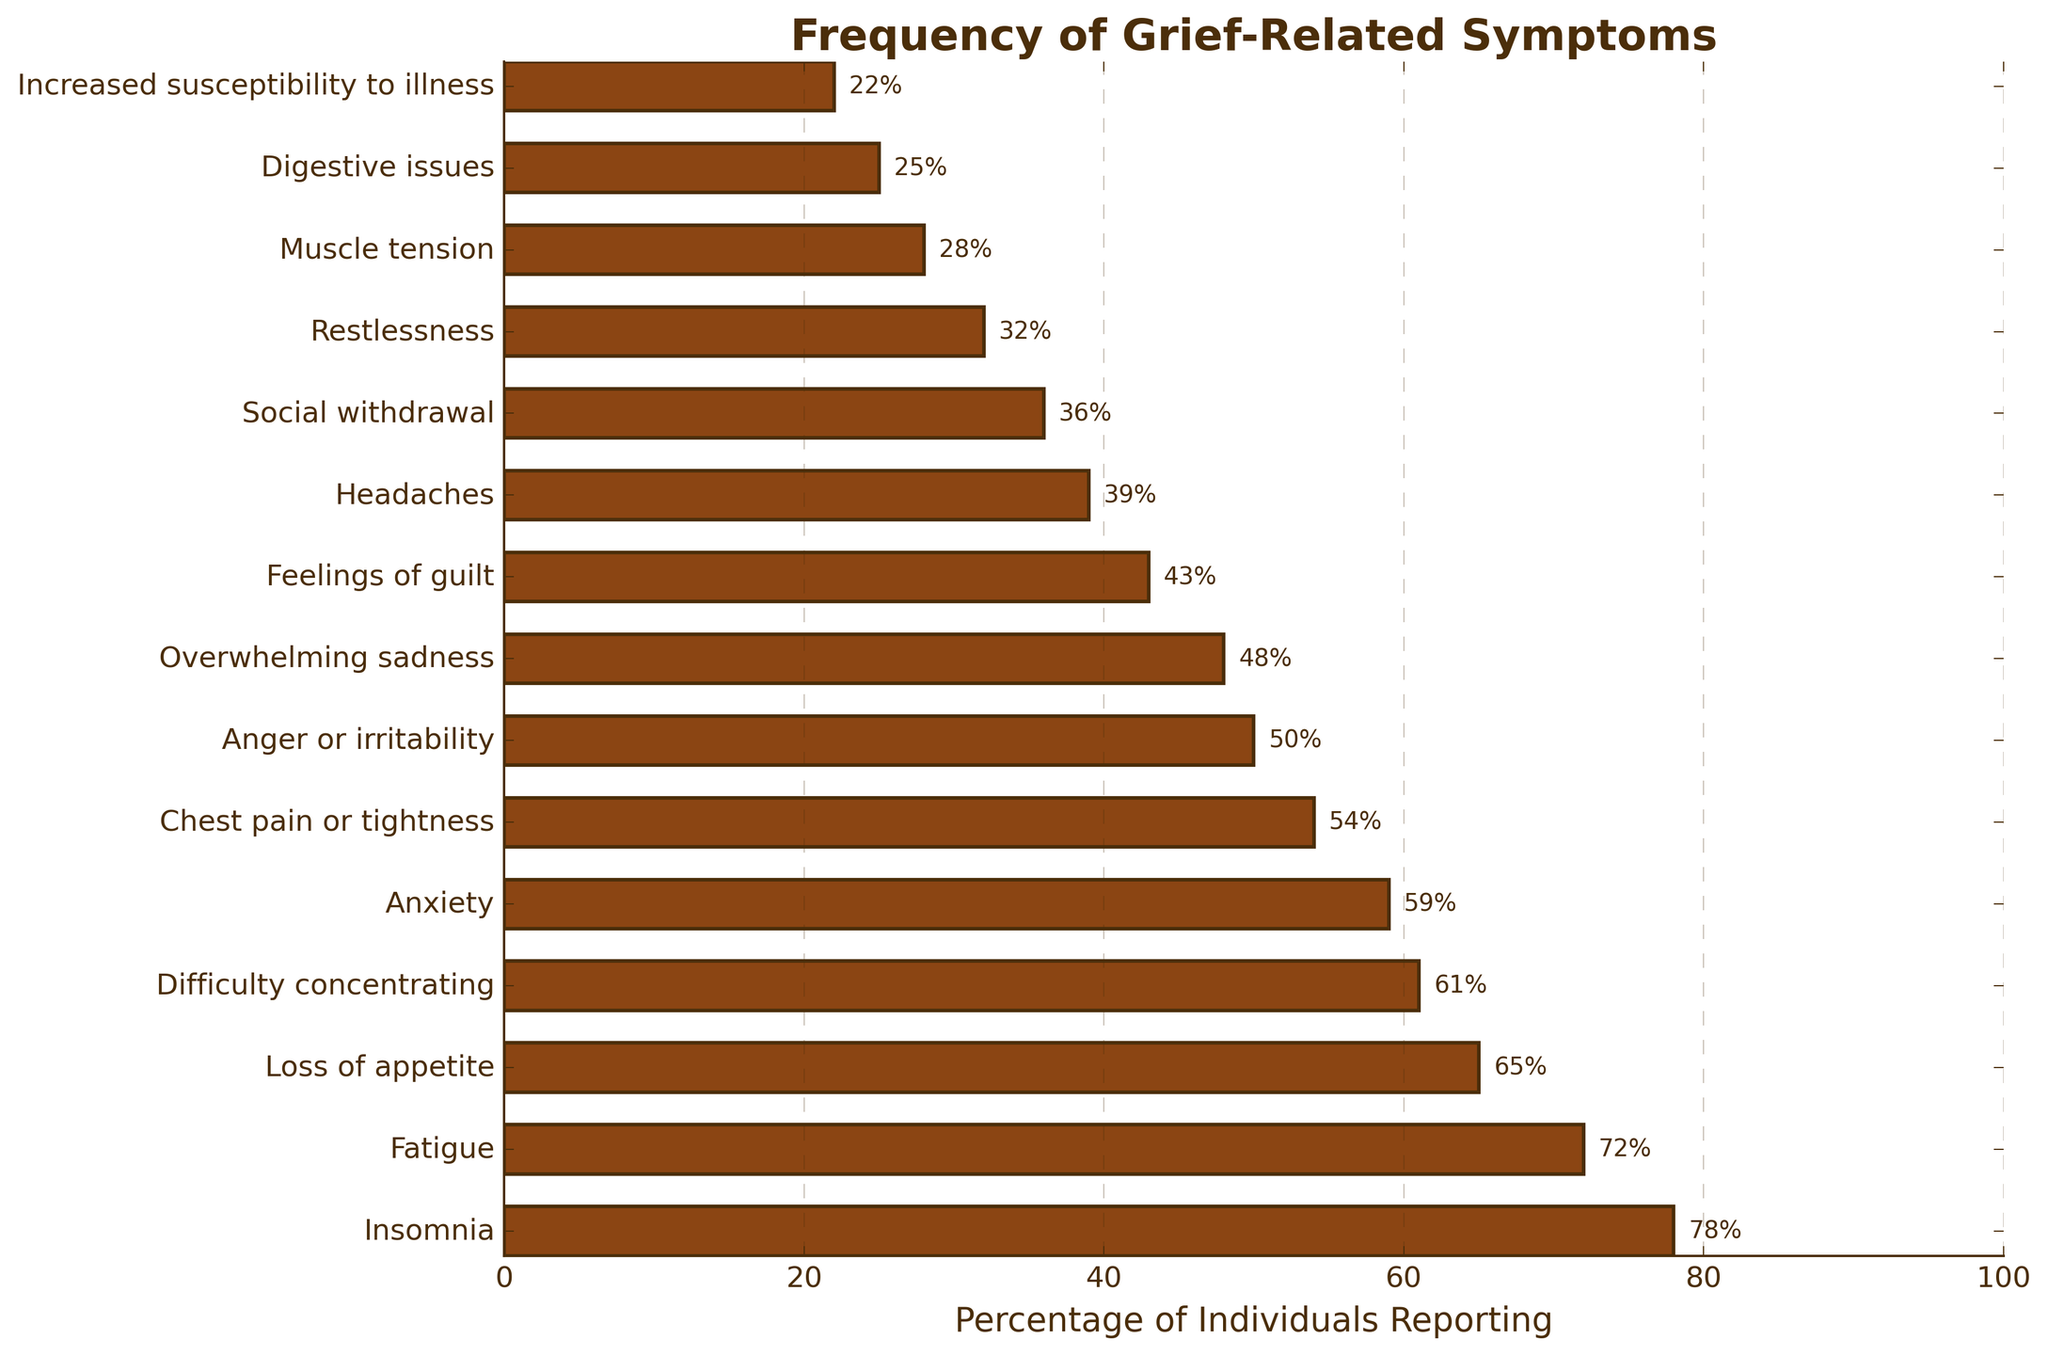What is the most frequently reported symptom during the grief process? The symptom with the highest bar length represents the most frequently reported symptom. In the chart, "Insomnia" has the highest percentage.
Answer: Insomnia Which symptom is reported more frequently: "Anger or irritability" or "Headaches"? Compare the bar lengths for "Anger or irritability" and "Headaches." "Anger or irritability" is at 50%, and "Headaches" is at 39%.
Answer: Anger or irritability What is the percentage difference between "Fatigue" and "Loss of appetite"? Subtract the percentage of "Loss of appetite" from "Fatigue," which are 72% and 65%, respectively. 72% - 65% = 7%
Answer: 7% Which symptom has a percentage closest to 50%? Look for the bar with a value closest to 50%; "Anger or irritability" at 50% matches exactly.
Answer: Anger or irritability What are the three least frequently reported symptoms in the chart? Identify the shortest bars. "Increased susceptibility to illness" at 22%, "Digestive issues" at 25%, and "Muscle tension" at 28% are the three shortest.
Answer: Increased susceptibility to illness, Digestive issues, Muscle tension Is "Anxiety" reported more frequently than "Difficulty concentrating"? Compare the percentages for "Anxiety" and "Difficulty concentrating," which are 59% and 61%, respectively.
Answer: No By how much does the frequency of "Overwhelming sadness" exceed "Social withdrawal"? Subtract the percentage of "Social withdrawal" from "Overwhelming sadness," which are 48% and 36%, respectively. 48% - 36% = 12%
Answer: 12% What is the combined percentage of individuals reporting "Feelings of guilt" and "Headaches"? Sum the percentages for "Feelings of guilt" and "Headaches," which are 43% and 39%, respectively. 43% + 39% = 82%
Answer: 82% How does the frequency of "Restlessness" compare to "Digestive issues"? "Restlessness" has a percentage of 32% and "Digestive issues" has 25%. 32% - 25% = 7%. "Restlessness" is reported 7% more frequently.
Answer: Restlessness is reported 7% more frequently What is the average frequency of the top five most reported symptoms? Sum the percentages of the top five symptoms: Insomnia (78%), Fatigue (72%), Loss of appetite (65%), Difficulty concentrating (61%), and Anxiety (59%). (78 + 72 + 65 + 61 + 59) / 5 = 335 / 5 = 67%
Answer: 67% 